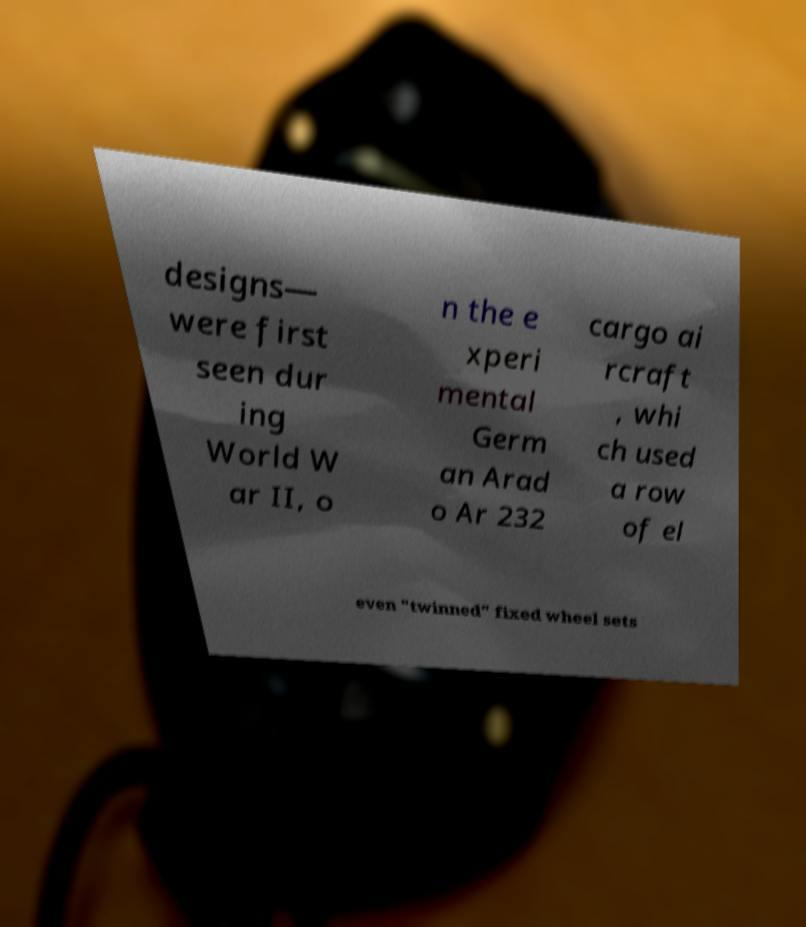There's text embedded in this image that I need extracted. Can you transcribe it verbatim? designs— were first seen dur ing World W ar II, o n the e xperi mental Germ an Arad o Ar 232 cargo ai rcraft , whi ch used a row of el even "twinned" fixed wheel sets 